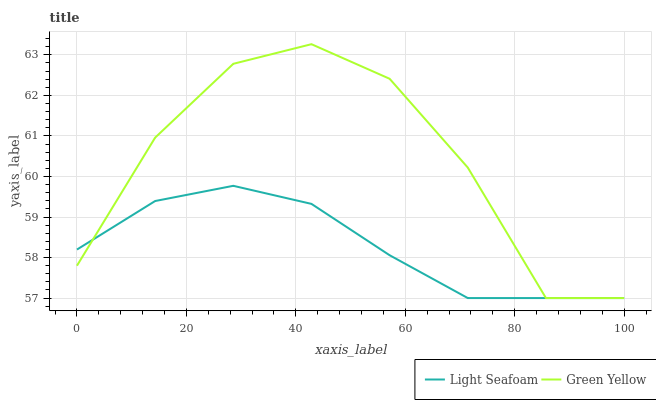Does Light Seafoam have the minimum area under the curve?
Answer yes or no. Yes. Does Green Yellow have the maximum area under the curve?
Answer yes or no. Yes. Does Light Seafoam have the maximum area under the curve?
Answer yes or no. No. Is Light Seafoam the smoothest?
Answer yes or no. Yes. Is Green Yellow the roughest?
Answer yes or no. Yes. Is Light Seafoam the roughest?
Answer yes or no. No. Does Green Yellow have the highest value?
Answer yes or no. Yes. Does Light Seafoam have the highest value?
Answer yes or no. No. Does Light Seafoam intersect Green Yellow?
Answer yes or no. Yes. Is Light Seafoam less than Green Yellow?
Answer yes or no. No. Is Light Seafoam greater than Green Yellow?
Answer yes or no. No. 